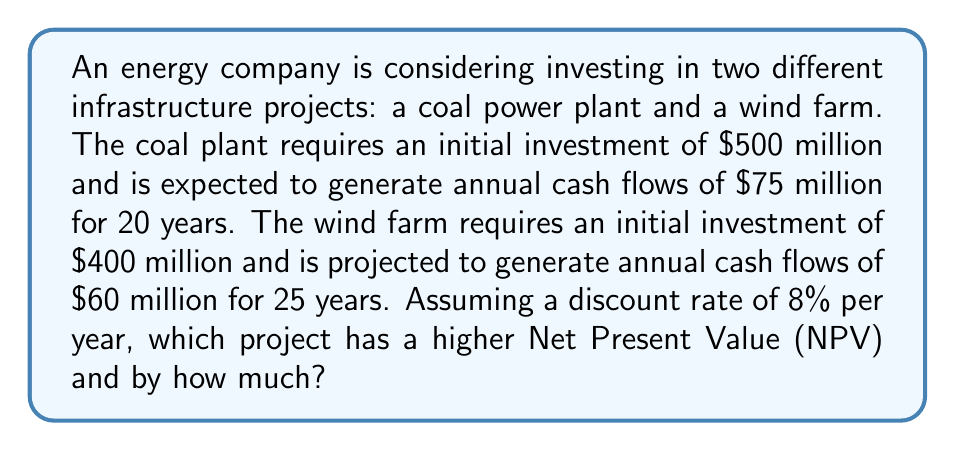Give your solution to this math problem. To solve this problem, we need to calculate the Net Present Value (NPV) for each project using the present value formula for annuities and then compare them. The NPV is the difference between the present value of cash inflows and the initial investment.

1. Coal Power Plant:
   - Initial investment: $500 million
   - Annual cash flow: $75 million
   - Time period: 20 years
   - Discount rate: 8%

   The present value of the annuity is given by:
   $$PV = A \cdot \frac{1 - (1+r)^{-n}}{r}$$
   where $A$ is the annual cash flow, $r$ is the discount rate, and $n$ is the number of years.

   $$PV_{coal} = 75 \cdot \frac{1 - (1+0.08)^{-20}}{0.08} = 75 \cdot 9.8181 = 736.3575$$

   NPV for coal plant:
   $$NPV_{coal} = 736.3575 - 500 = 236.3575\text{ million}$$

2. Wind Farm:
   - Initial investment: $400 million
   - Annual cash flow: $60 million
   - Time period: 25 years
   - Discount rate: 8%

   $$PV_{wind} = 60 \cdot \frac{1 - (1+0.08)^{-25}}{0.08} = 60 \cdot 10.6748 = 640.4880$$

   NPV for wind farm:
   $$NPV_{wind} = 640.4880 - 400 = 240.4880\text{ million}$$

3. Comparing the NPVs:
   $$\text{Difference} = NPV_{wind} - NPV_{coal} = 240.4880 - 236.3575 = 4.1305\text{ million}$$
Answer: The wind farm project has a higher Net Present Value, exceeding the coal power plant project by $4.1305 million. 